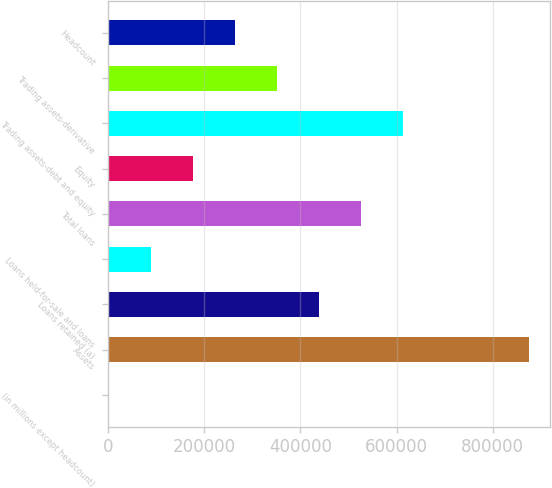<chart> <loc_0><loc_0><loc_500><loc_500><bar_chart><fcel>(in millions except headcount)<fcel>Assets<fcel>Loans retained (a)<fcel>Loans held-for-sale and loans<fcel>Total loans<fcel>Equity<fcel>Trading assets-debt and equity<fcel>Trading assets-derivative<fcel>Headcount<nl><fcel>2012<fcel>876107<fcel>439060<fcel>89421.5<fcel>526469<fcel>176831<fcel>613878<fcel>351650<fcel>264240<nl></chart> 